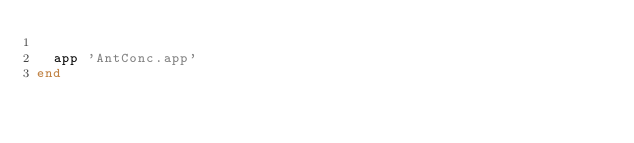Convert code to text. <code><loc_0><loc_0><loc_500><loc_500><_Ruby_>
  app 'AntConc.app'
end
</code> 